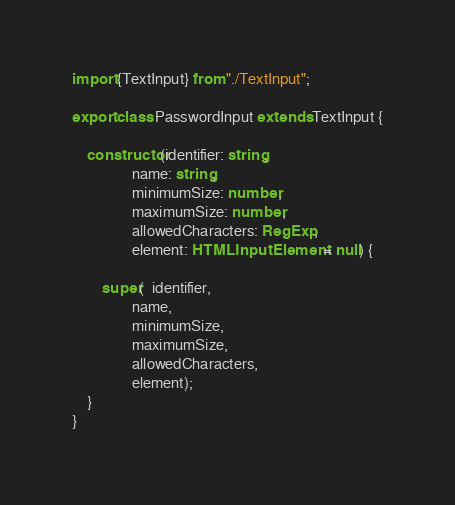<code> <loc_0><loc_0><loc_500><loc_500><_TypeScript_>import {TextInput} from "./TextInput";

export class PasswordInput extends TextInput {

    constructor(identifier: string,
                name: string,
                minimumSize: number,
                maximumSize: number,
                allowedCharacters: RegExp,
                element: HTMLInputElement = null) {

        super(  identifier,
                name,
                minimumSize,
                maximumSize,
                allowedCharacters,
                element);
    }
}</code> 